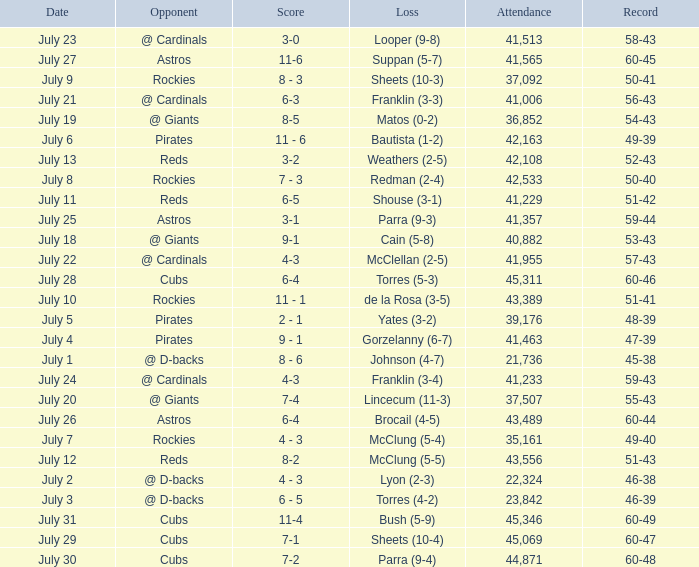What's the attendance of the game where there was a Loss of Yates (3-2)? 39176.0. 